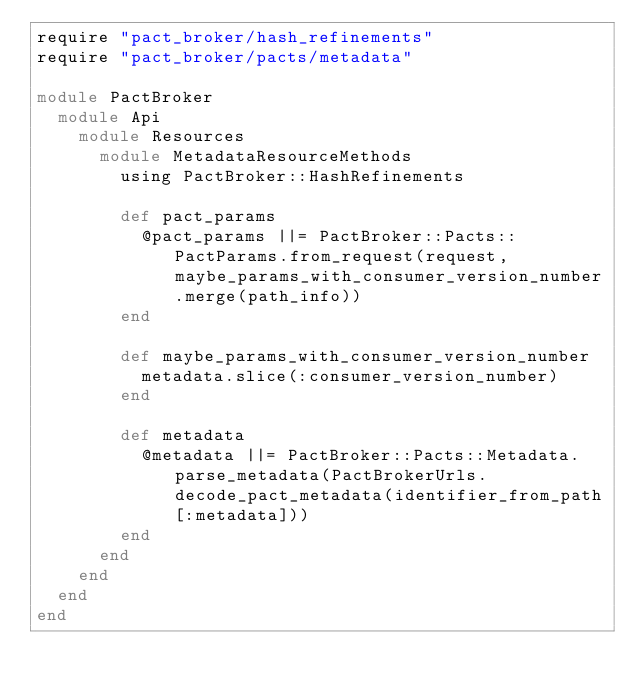Convert code to text. <code><loc_0><loc_0><loc_500><loc_500><_Ruby_>require "pact_broker/hash_refinements"
require "pact_broker/pacts/metadata"

module PactBroker
  module Api
    module Resources
      module MetadataResourceMethods
        using PactBroker::HashRefinements

        def pact_params
          @pact_params ||= PactBroker::Pacts::PactParams.from_request(request, maybe_params_with_consumer_version_number.merge(path_info))
        end

        def maybe_params_with_consumer_version_number
          metadata.slice(:consumer_version_number)
        end

        def metadata
          @metadata ||= PactBroker::Pacts::Metadata.parse_metadata(PactBrokerUrls.decode_pact_metadata(identifier_from_path[:metadata]))
        end
      end
    end
  end
end
</code> 